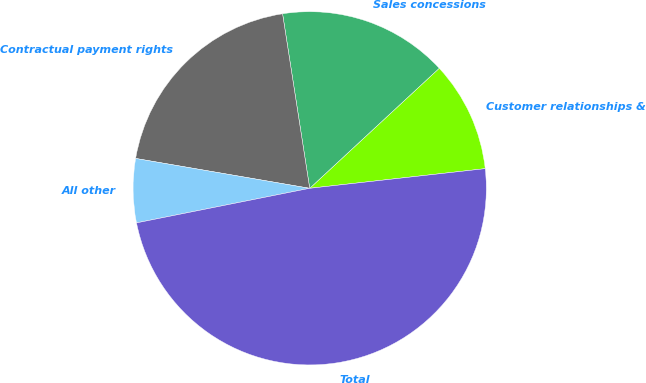Convert chart to OTSL. <chart><loc_0><loc_0><loc_500><loc_500><pie_chart><fcel>Customer relationships &<fcel>Sales concessions<fcel>Contractual payment rights<fcel>All other<fcel>Total<nl><fcel>10.12%<fcel>15.56%<fcel>19.84%<fcel>5.84%<fcel>48.64%<nl></chart> 